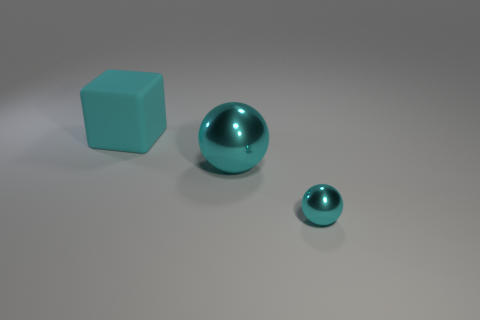Add 3 small cyan spheres. How many objects exist? 6 Subtract all balls. How many objects are left? 1 Add 3 big yellow blocks. How many big yellow blocks exist? 3 Subtract 0 cyan cylinders. How many objects are left? 3 Subtract all big blue cylinders. Subtract all tiny cyan objects. How many objects are left? 2 Add 3 big cyan metal objects. How many big cyan metal objects are left? 4 